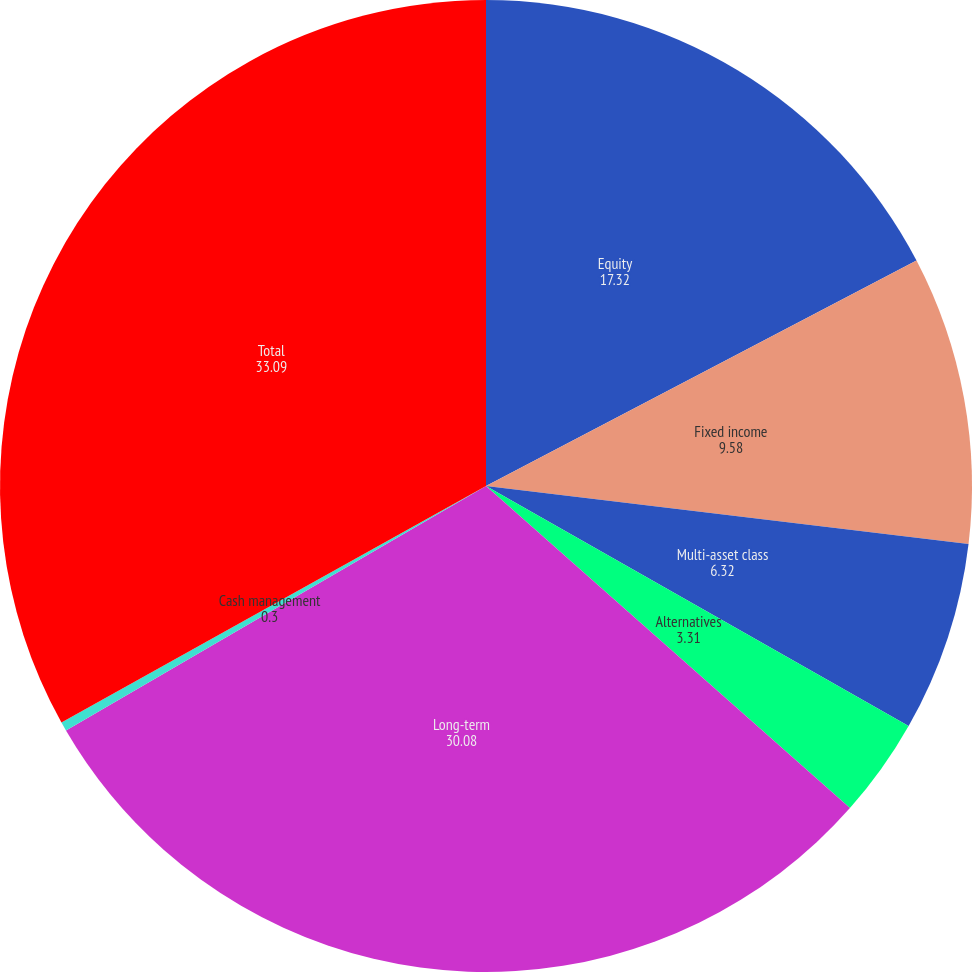<chart> <loc_0><loc_0><loc_500><loc_500><pie_chart><fcel>Equity<fcel>Fixed income<fcel>Multi-asset class<fcel>Alternatives<fcel>Long-term<fcel>Cash management<fcel>Total<nl><fcel>17.32%<fcel>9.58%<fcel>6.32%<fcel>3.31%<fcel>30.08%<fcel>0.3%<fcel>33.09%<nl></chart> 